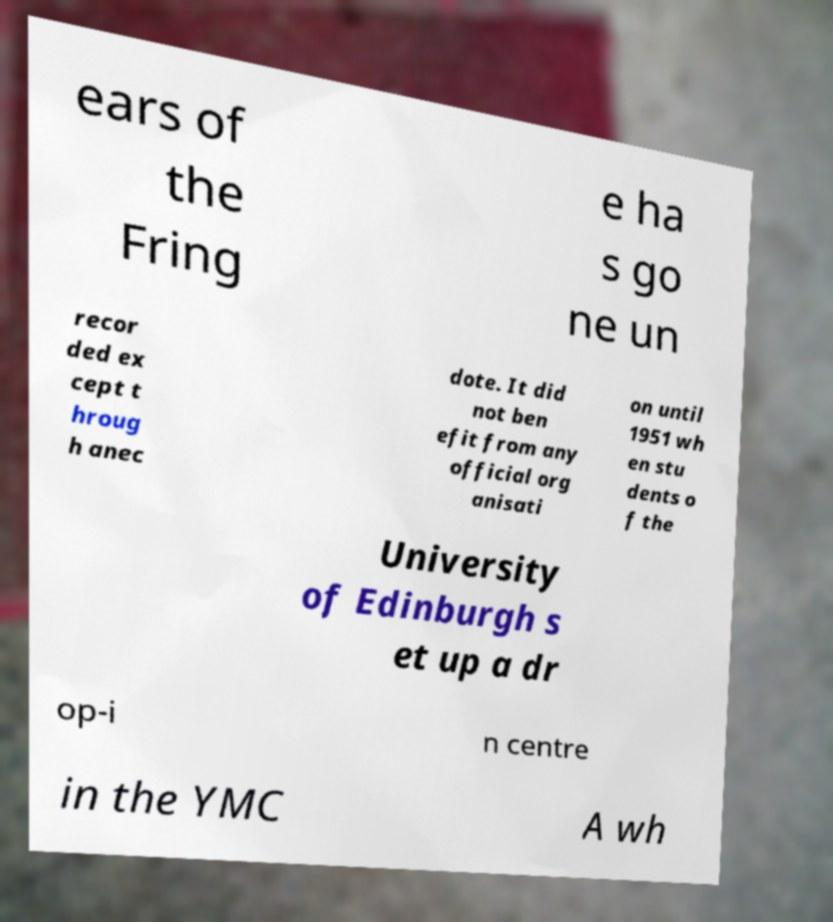Please identify and transcribe the text found in this image. ears of the Fring e ha s go ne un recor ded ex cept t hroug h anec dote. It did not ben efit from any official org anisati on until 1951 wh en stu dents o f the University of Edinburgh s et up a dr op-i n centre in the YMC A wh 